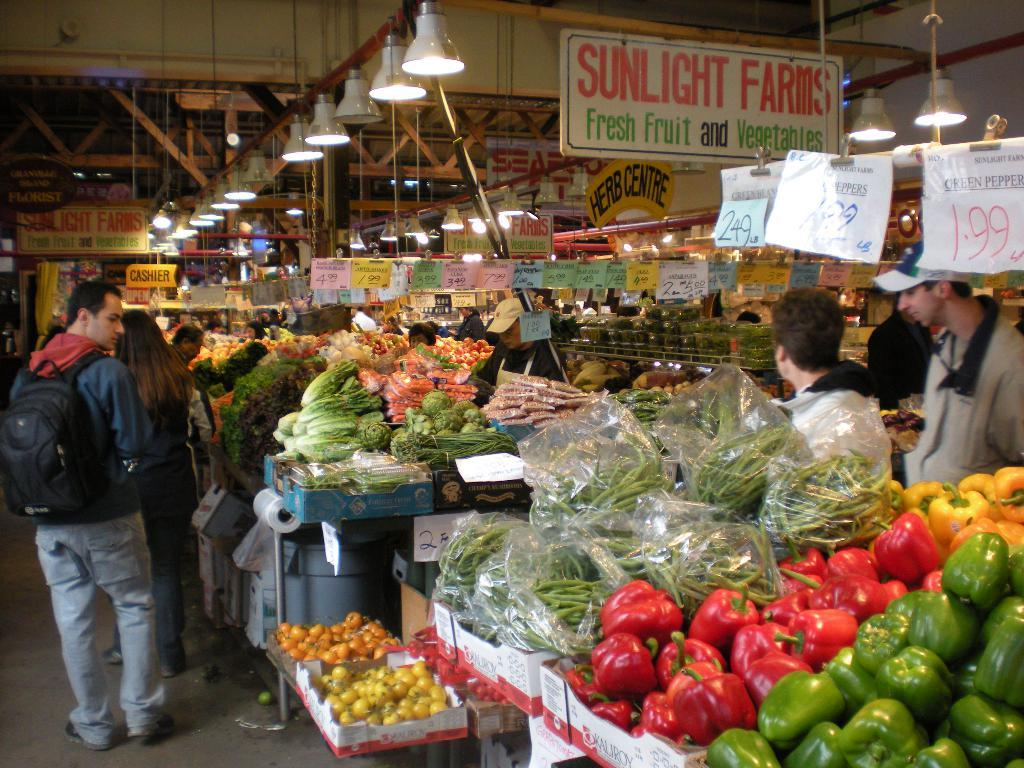What type of food is in the cardboard boxes in the image? There are vegetables in the cardboard boxes in the image. Who or what can be seen standing in the image? There are people standing in the image. What objects are visible in the image that are made of wood or a similar material? There are boards visible in the image. What can be seen in the background of the image that provides illumination? There are lights in the background of the image. What type of pet can be seen playing with a force in the image? There is no pet or force present in the image. 